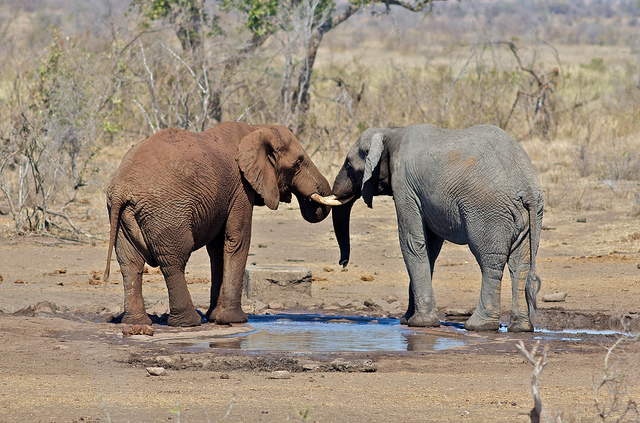<image>Do all of the elephants have tusks? I don't know if all the elephants have tusks. It can be both yes and no. Do all of the elephants have tusks? I don't know if all of the elephants have tusks. Some of them may have tusks while others do not. 